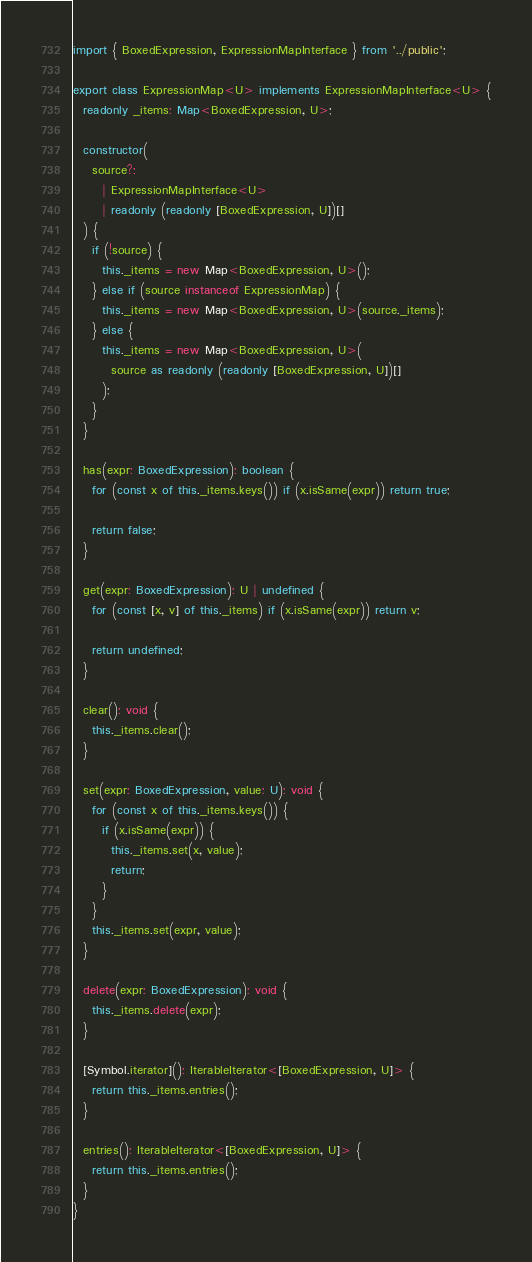<code> <loc_0><loc_0><loc_500><loc_500><_TypeScript_>import { BoxedExpression, ExpressionMapInterface } from '../public';

export class ExpressionMap<U> implements ExpressionMapInterface<U> {
  readonly _items: Map<BoxedExpression, U>;

  constructor(
    source?:
      | ExpressionMapInterface<U>
      | readonly (readonly [BoxedExpression, U])[]
  ) {
    if (!source) {
      this._items = new Map<BoxedExpression, U>();
    } else if (source instanceof ExpressionMap) {
      this._items = new Map<BoxedExpression, U>(source._items);
    } else {
      this._items = new Map<BoxedExpression, U>(
        source as readonly (readonly [BoxedExpression, U])[]
      );
    }
  }

  has(expr: BoxedExpression): boolean {
    for (const x of this._items.keys()) if (x.isSame(expr)) return true;

    return false;
  }

  get(expr: BoxedExpression): U | undefined {
    for (const [x, v] of this._items) if (x.isSame(expr)) return v;

    return undefined;
  }

  clear(): void {
    this._items.clear();
  }

  set(expr: BoxedExpression, value: U): void {
    for (const x of this._items.keys()) {
      if (x.isSame(expr)) {
        this._items.set(x, value);
        return;
      }
    }
    this._items.set(expr, value);
  }

  delete(expr: BoxedExpression): void {
    this._items.delete(expr);
  }

  [Symbol.iterator](): IterableIterator<[BoxedExpression, U]> {
    return this._items.entries();
  }

  entries(): IterableIterator<[BoxedExpression, U]> {
    return this._items.entries();
  }
}
</code> 